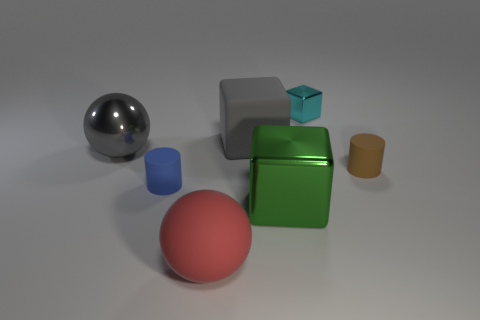What number of large red things have the same shape as the cyan metallic thing?
Ensure brevity in your answer.  0. There is a cyan thing; does it have the same shape as the big matte object in front of the tiny blue object?
Provide a short and direct response. No. There is a big thing that is the same color as the large rubber block; what is its shape?
Offer a terse response. Sphere. Are there any big blocks made of the same material as the small cyan object?
Keep it short and to the point. Yes. Is there any other thing that is the same material as the red thing?
Offer a very short reply. Yes. There is a tiny thing that is left of the big rubber object behind the tiny brown cylinder; what is it made of?
Provide a succinct answer. Rubber. There is a sphere in front of the big shiny thing in front of the small matte thing on the left side of the small cyan metallic cube; what is its size?
Your answer should be very brief. Large. How many other things are there of the same shape as the big green object?
Your answer should be compact. 2. Do the metallic block that is in front of the large gray rubber cube and the tiny rubber thing to the right of the tiny cyan shiny cube have the same color?
Provide a short and direct response. No. What is the color of the metallic cube that is the same size as the brown object?
Keep it short and to the point. Cyan. 